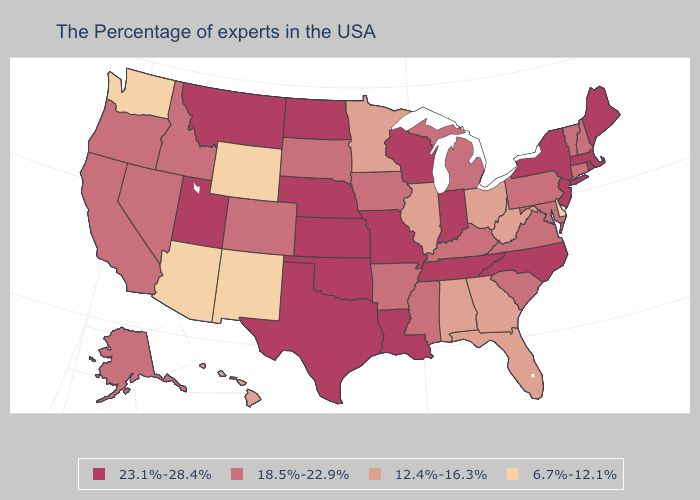Does the map have missing data?
Write a very short answer. No. Name the states that have a value in the range 6.7%-12.1%?
Short answer required. Delaware, Wyoming, New Mexico, Arizona, Washington. Does Wyoming have the highest value in the West?
Answer briefly. No. Name the states that have a value in the range 23.1%-28.4%?
Give a very brief answer. Maine, Massachusetts, Rhode Island, New York, New Jersey, North Carolina, Indiana, Tennessee, Wisconsin, Louisiana, Missouri, Kansas, Nebraska, Oklahoma, Texas, North Dakota, Utah, Montana. Does Alabama have a lower value than Louisiana?
Short answer required. Yes. Name the states that have a value in the range 23.1%-28.4%?
Give a very brief answer. Maine, Massachusetts, Rhode Island, New York, New Jersey, North Carolina, Indiana, Tennessee, Wisconsin, Louisiana, Missouri, Kansas, Nebraska, Oklahoma, Texas, North Dakota, Utah, Montana. Name the states that have a value in the range 23.1%-28.4%?
Short answer required. Maine, Massachusetts, Rhode Island, New York, New Jersey, North Carolina, Indiana, Tennessee, Wisconsin, Louisiana, Missouri, Kansas, Nebraska, Oklahoma, Texas, North Dakota, Utah, Montana. What is the value of Missouri?
Write a very short answer. 23.1%-28.4%. Name the states that have a value in the range 12.4%-16.3%?
Answer briefly. West Virginia, Ohio, Florida, Georgia, Alabama, Illinois, Minnesota, Hawaii. What is the value of North Carolina?
Answer briefly. 23.1%-28.4%. Among the states that border Florida , which have the lowest value?
Keep it brief. Georgia, Alabama. Does Oklahoma have the highest value in the USA?
Give a very brief answer. Yes. Does Alabama have the lowest value in the South?
Short answer required. No. What is the value of Maryland?
Write a very short answer. 18.5%-22.9%. Name the states that have a value in the range 6.7%-12.1%?
Be succinct. Delaware, Wyoming, New Mexico, Arizona, Washington. 